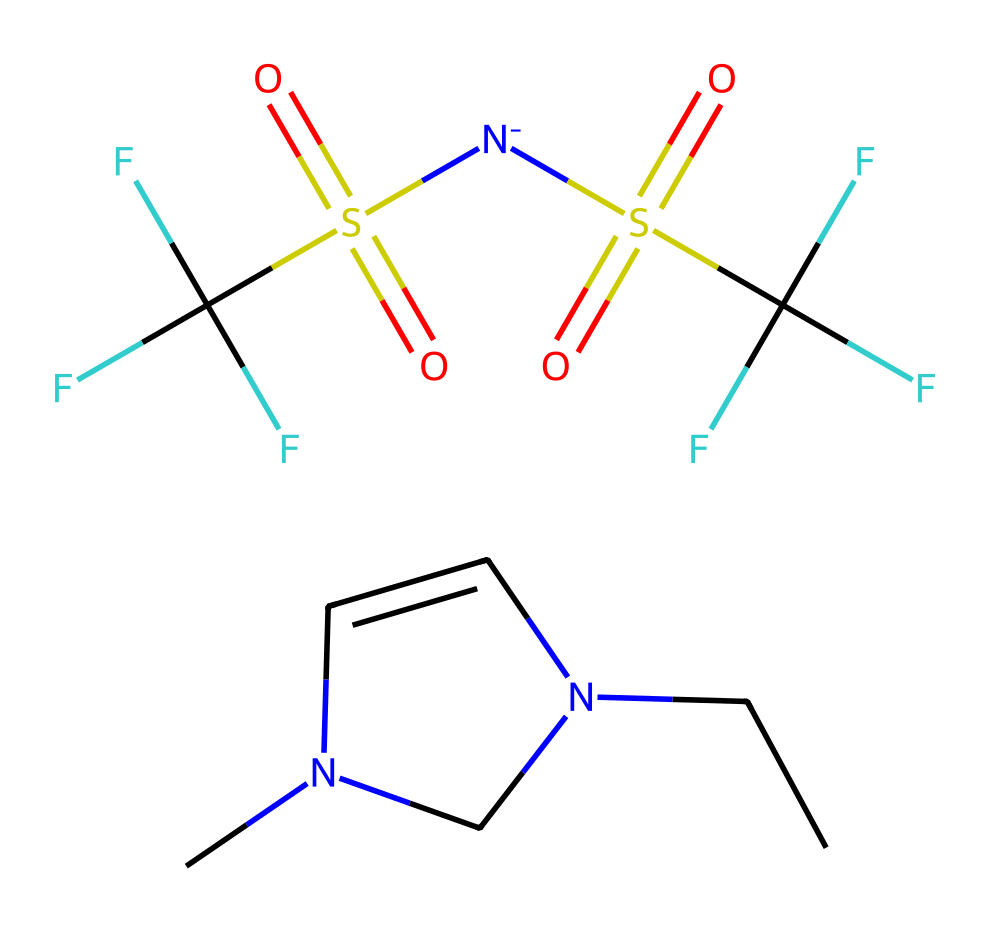how many nitrogen atoms are present in this ionic liquid? The SMILES representation shows two instances of the letter 'N', indicating the presence of two nitrogen atoms in the structure.
Answer: 2 what is the main characteristic feature of ionic liquids in this structure? The presence of both a cation (the first part of the SMILES) and an anion (the second part of the SMILES) indicates that this molecule is an ionic liquid, which typically consists of these charged components.
Answer: cation and anion how many fluorine atoms are present in the anion of this ionic liquid? In the SMILES notation, the part that represents the anion includes 'C(F)(F)F', indicating that there are three fluorine atoms attached to that carbon.
Answer: 6 which element in this ionic liquid is responsible for its ionic character? The presence of nitrogen (as cation) and sulfur (in the anion) allows the molecule to have charged components, which contributes to its ionic character.
Answer: nitrogen and sulfur what type of bond primarily connects the cation and anion in this ionic liquid? Ionic bonds primarily connect the cation and anion in ionic liquids, formed due to the electrostatic attraction between the positively charged cation and negatively charged anion.
Answer: ionic bond what purpose do the sulfonate groups serve in this ionic liquid? Sulfonate groups enhance the solubility of ionic liquids and contribute to their ionic conductivity, which is essential for electrolyte applications in batteries.
Answer: enhance solubility and conductivity 